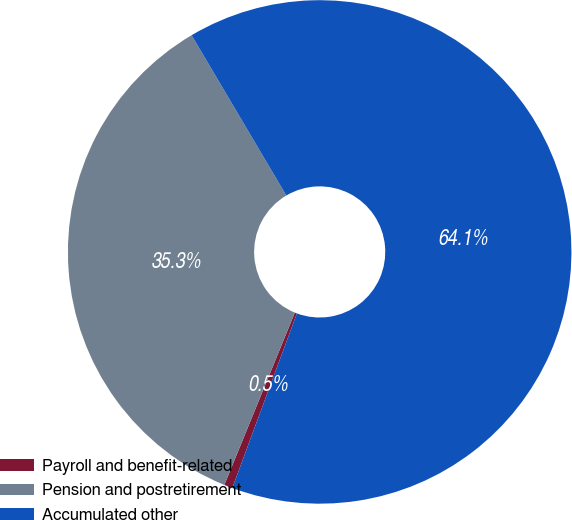<chart> <loc_0><loc_0><loc_500><loc_500><pie_chart><fcel>Payroll and benefit-related<fcel>Pension and postretirement<fcel>Accumulated other<nl><fcel>0.54%<fcel>35.32%<fcel>64.14%<nl></chart> 